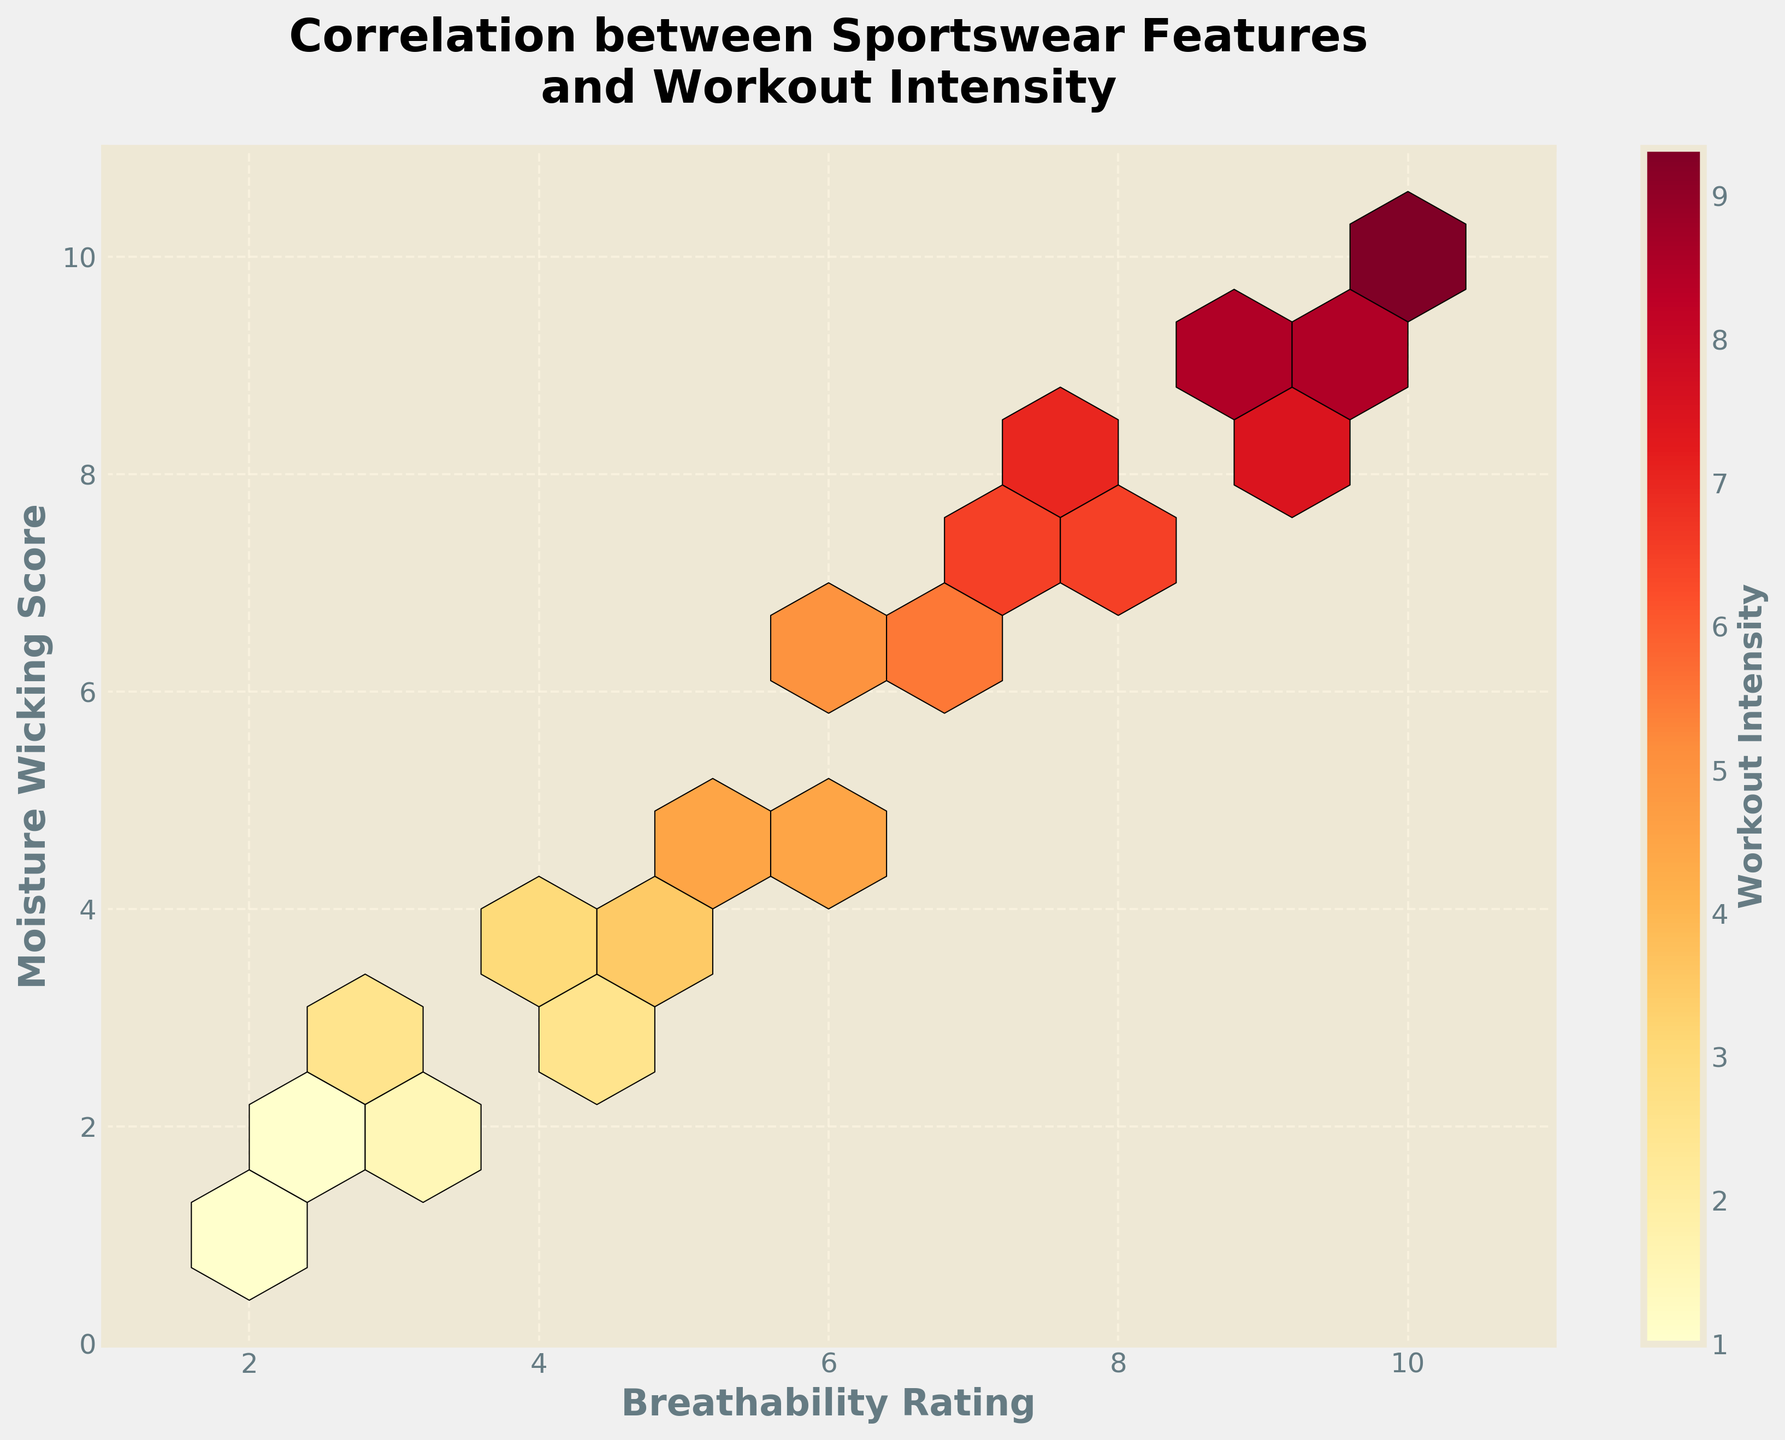What is the title of the plot? The title of the plot is found at the top of the figure. It usually describes the main topic or insight that the figure visualizes. The title for this plot is "Correlation between Sportswear Features and Workout Intensity".
Answer: Correlation between Sportswear Features and Workout Intensity What are the labels of the x and y axes? The labels for the x and y axes are found along the respective axes. The x-axis label is "Breathability Rating" and the y-axis label is "Moisture Wicking Score".
Answer: Breathability Rating and Moisture Wicking Score What does the color intensity represent in the plot? The color intensity in the hexbin plot represents the "Workout Intensity". This can be observed from the legend or color bar labeled "Workout Intensity" on the side of the plot.
Answer: Workout Intensity What is the range of the breathability rating on the x-axis? The range of the breathability rating is determined by looking at the values on the x-axis. The range goes from 1 to 11.
Answer: 1 to 11 How many hexagons have the highest intensity of color? To determine the number of hexagons with the highest intensity of color, one must observe the color map and identify the darkest hexagons, which correspond to the highest workout intensity.
Answer: 1 How does breathability rating correlate with moisture wicking score? By examining the hexbin plot, one can see that as the breathability rating increases, the moisture wicking score tends to increase as well. The concentration of hexagons forms a pattern from the bottom-left to the top-right, indicating a positive correlation.
Answer: Positive correlation Which breathability rating range seems to have the highest density of data points? The density of data points can be determined by the number of filled hexagons in a specific range of the x-axis. The breathability rating range that has the highest density of data points appears to be between 4 to 8.
Answer: 4 to 8 Does the plot suggest any clusters or specific groupings? Observing the hexbin plot, one can identify that there are clusters of higher data density in certain regions. Specifically, there appears to be a significant grouping of data points in the middle of the plot around the breathability rating of 5-7 and moisture wicking scores of 5-7.
Answer: Yes, middle regions Between breathability ratings of 2 and 4, what are the ranges of moisture-wicking scores? To find the range of moisture-wicking scores for breathability ratings between 2 and 4, observe the vertical spread of hexagons in this x-axis interval. The scores range from approximately 2 to 6.
Answer: 2 to 6 